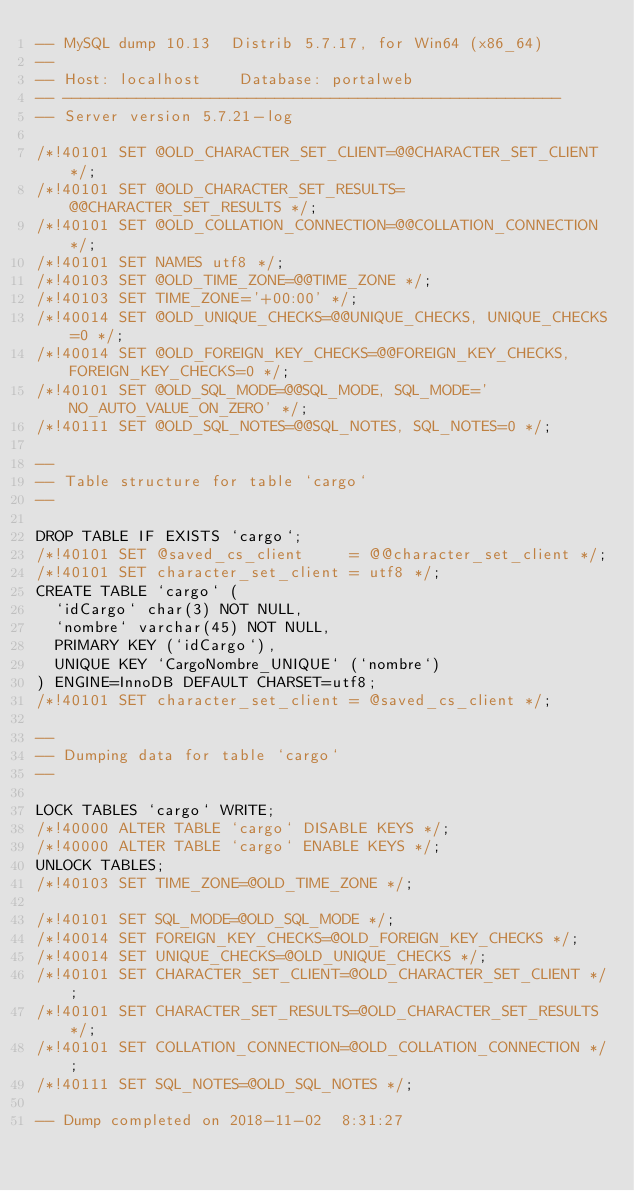<code> <loc_0><loc_0><loc_500><loc_500><_SQL_>-- MySQL dump 10.13  Distrib 5.7.17, for Win64 (x86_64)
--
-- Host: localhost    Database: portalweb
-- ------------------------------------------------------
-- Server version	5.7.21-log

/*!40101 SET @OLD_CHARACTER_SET_CLIENT=@@CHARACTER_SET_CLIENT */;
/*!40101 SET @OLD_CHARACTER_SET_RESULTS=@@CHARACTER_SET_RESULTS */;
/*!40101 SET @OLD_COLLATION_CONNECTION=@@COLLATION_CONNECTION */;
/*!40101 SET NAMES utf8 */;
/*!40103 SET @OLD_TIME_ZONE=@@TIME_ZONE */;
/*!40103 SET TIME_ZONE='+00:00' */;
/*!40014 SET @OLD_UNIQUE_CHECKS=@@UNIQUE_CHECKS, UNIQUE_CHECKS=0 */;
/*!40014 SET @OLD_FOREIGN_KEY_CHECKS=@@FOREIGN_KEY_CHECKS, FOREIGN_KEY_CHECKS=0 */;
/*!40101 SET @OLD_SQL_MODE=@@SQL_MODE, SQL_MODE='NO_AUTO_VALUE_ON_ZERO' */;
/*!40111 SET @OLD_SQL_NOTES=@@SQL_NOTES, SQL_NOTES=0 */;

--
-- Table structure for table `cargo`
--

DROP TABLE IF EXISTS `cargo`;
/*!40101 SET @saved_cs_client     = @@character_set_client */;
/*!40101 SET character_set_client = utf8 */;
CREATE TABLE `cargo` (
  `idCargo` char(3) NOT NULL,
  `nombre` varchar(45) NOT NULL,
  PRIMARY KEY (`idCargo`),
  UNIQUE KEY `CargoNombre_UNIQUE` (`nombre`)
) ENGINE=InnoDB DEFAULT CHARSET=utf8;
/*!40101 SET character_set_client = @saved_cs_client */;

--
-- Dumping data for table `cargo`
--

LOCK TABLES `cargo` WRITE;
/*!40000 ALTER TABLE `cargo` DISABLE KEYS */;
/*!40000 ALTER TABLE `cargo` ENABLE KEYS */;
UNLOCK TABLES;
/*!40103 SET TIME_ZONE=@OLD_TIME_ZONE */;

/*!40101 SET SQL_MODE=@OLD_SQL_MODE */;
/*!40014 SET FOREIGN_KEY_CHECKS=@OLD_FOREIGN_KEY_CHECKS */;
/*!40014 SET UNIQUE_CHECKS=@OLD_UNIQUE_CHECKS */;
/*!40101 SET CHARACTER_SET_CLIENT=@OLD_CHARACTER_SET_CLIENT */;
/*!40101 SET CHARACTER_SET_RESULTS=@OLD_CHARACTER_SET_RESULTS */;
/*!40101 SET COLLATION_CONNECTION=@OLD_COLLATION_CONNECTION */;
/*!40111 SET SQL_NOTES=@OLD_SQL_NOTES */;

-- Dump completed on 2018-11-02  8:31:27
</code> 